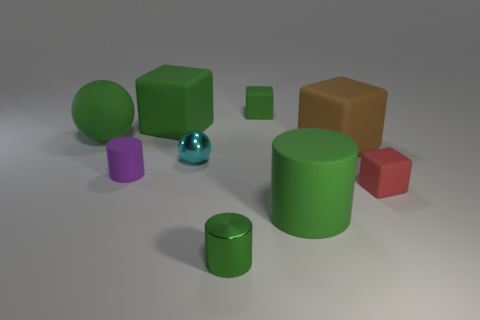Subtract all large brown cubes. How many cubes are left? 3 Subtract all yellow spheres. How many green cylinders are left? 2 Add 1 big green matte balls. How many objects exist? 10 Subtract 2 cubes. How many cubes are left? 2 Subtract all red cubes. How many cubes are left? 3 Subtract all cylinders. How many objects are left? 6 Subtract all yellow cylinders. Subtract all yellow blocks. How many cylinders are left? 3 Add 7 small rubber blocks. How many small rubber blocks are left? 9 Add 7 large green matte cubes. How many large green matte cubes exist? 8 Subtract 1 brown cubes. How many objects are left? 8 